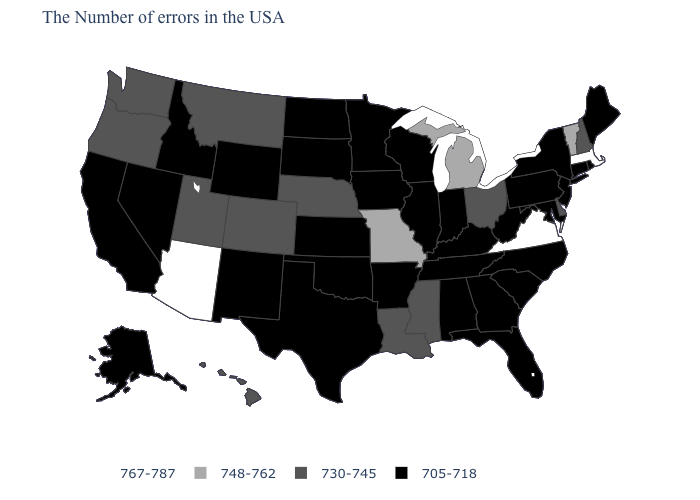What is the value of Wyoming?
Write a very short answer. 705-718. Name the states that have a value in the range 705-718?
Quick response, please. Maine, Rhode Island, Connecticut, New York, New Jersey, Maryland, Pennsylvania, North Carolina, South Carolina, West Virginia, Florida, Georgia, Kentucky, Indiana, Alabama, Tennessee, Wisconsin, Illinois, Arkansas, Minnesota, Iowa, Kansas, Oklahoma, Texas, South Dakota, North Dakota, Wyoming, New Mexico, Idaho, Nevada, California, Alaska. Among the states that border Florida , which have the lowest value?
Concise answer only. Georgia, Alabama. Does North Carolina have the same value as Wisconsin?
Give a very brief answer. Yes. Does the map have missing data?
Quick response, please. No. What is the value of Iowa?
Keep it brief. 705-718. Name the states that have a value in the range 748-762?
Quick response, please. Vermont, Michigan, Missouri. Name the states that have a value in the range 767-787?
Keep it brief. Massachusetts, Virginia, Arizona. Does Rhode Island have the lowest value in the USA?
Give a very brief answer. Yes. Among the states that border Wisconsin , which have the highest value?
Write a very short answer. Michigan. Name the states that have a value in the range 705-718?
Short answer required. Maine, Rhode Island, Connecticut, New York, New Jersey, Maryland, Pennsylvania, North Carolina, South Carolina, West Virginia, Florida, Georgia, Kentucky, Indiana, Alabama, Tennessee, Wisconsin, Illinois, Arkansas, Minnesota, Iowa, Kansas, Oklahoma, Texas, South Dakota, North Dakota, Wyoming, New Mexico, Idaho, Nevada, California, Alaska. Name the states that have a value in the range 705-718?
Write a very short answer. Maine, Rhode Island, Connecticut, New York, New Jersey, Maryland, Pennsylvania, North Carolina, South Carolina, West Virginia, Florida, Georgia, Kentucky, Indiana, Alabama, Tennessee, Wisconsin, Illinois, Arkansas, Minnesota, Iowa, Kansas, Oklahoma, Texas, South Dakota, North Dakota, Wyoming, New Mexico, Idaho, Nevada, California, Alaska. Does Vermont have a lower value than Arizona?
Write a very short answer. Yes. Which states have the highest value in the USA?
Write a very short answer. Massachusetts, Virginia, Arizona. 